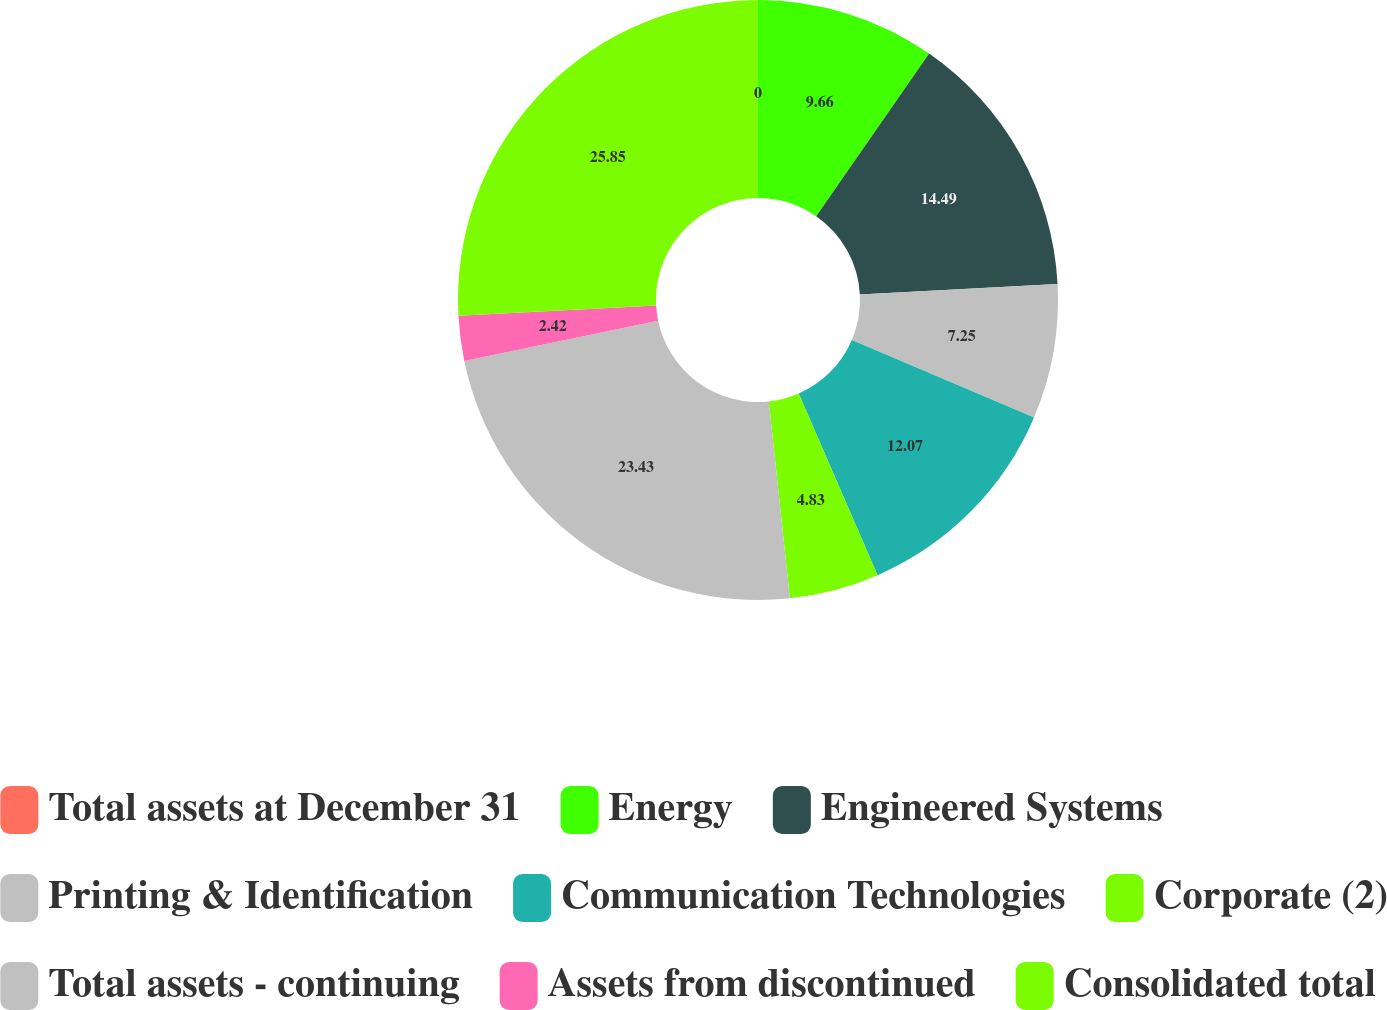Convert chart. <chart><loc_0><loc_0><loc_500><loc_500><pie_chart><fcel>Total assets at December 31<fcel>Energy<fcel>Engineered Systems<fcel>Printing & Identification<fcel>Communication Technologies<fcel>Corporate (2)<fcel>Total assets - continuing<fcel>Assets from discontinued<fcel>Consolidated total<nl><fcel>0.0%<fcel>9.66%<fcel>14.49%<fcel>7.25%<fcel>12.07%<fcel>4.83%<fcel>23.43%<fcel>2.42%<fcel>25.84%<nl></chart> 